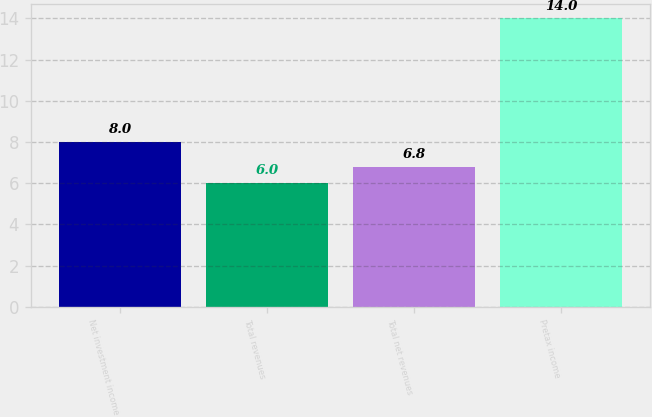Convert chart to OTSL. <chart><loc_0><loc_0><loc_500><loc_500><bar_chart><fcel>Net investment income<fcel>Total revenues<fcel>Total net revenues<fcel>Pretax income<nl><fcel>8<fcel>6<fcel>6.8<fcel>14<nl></chart> 